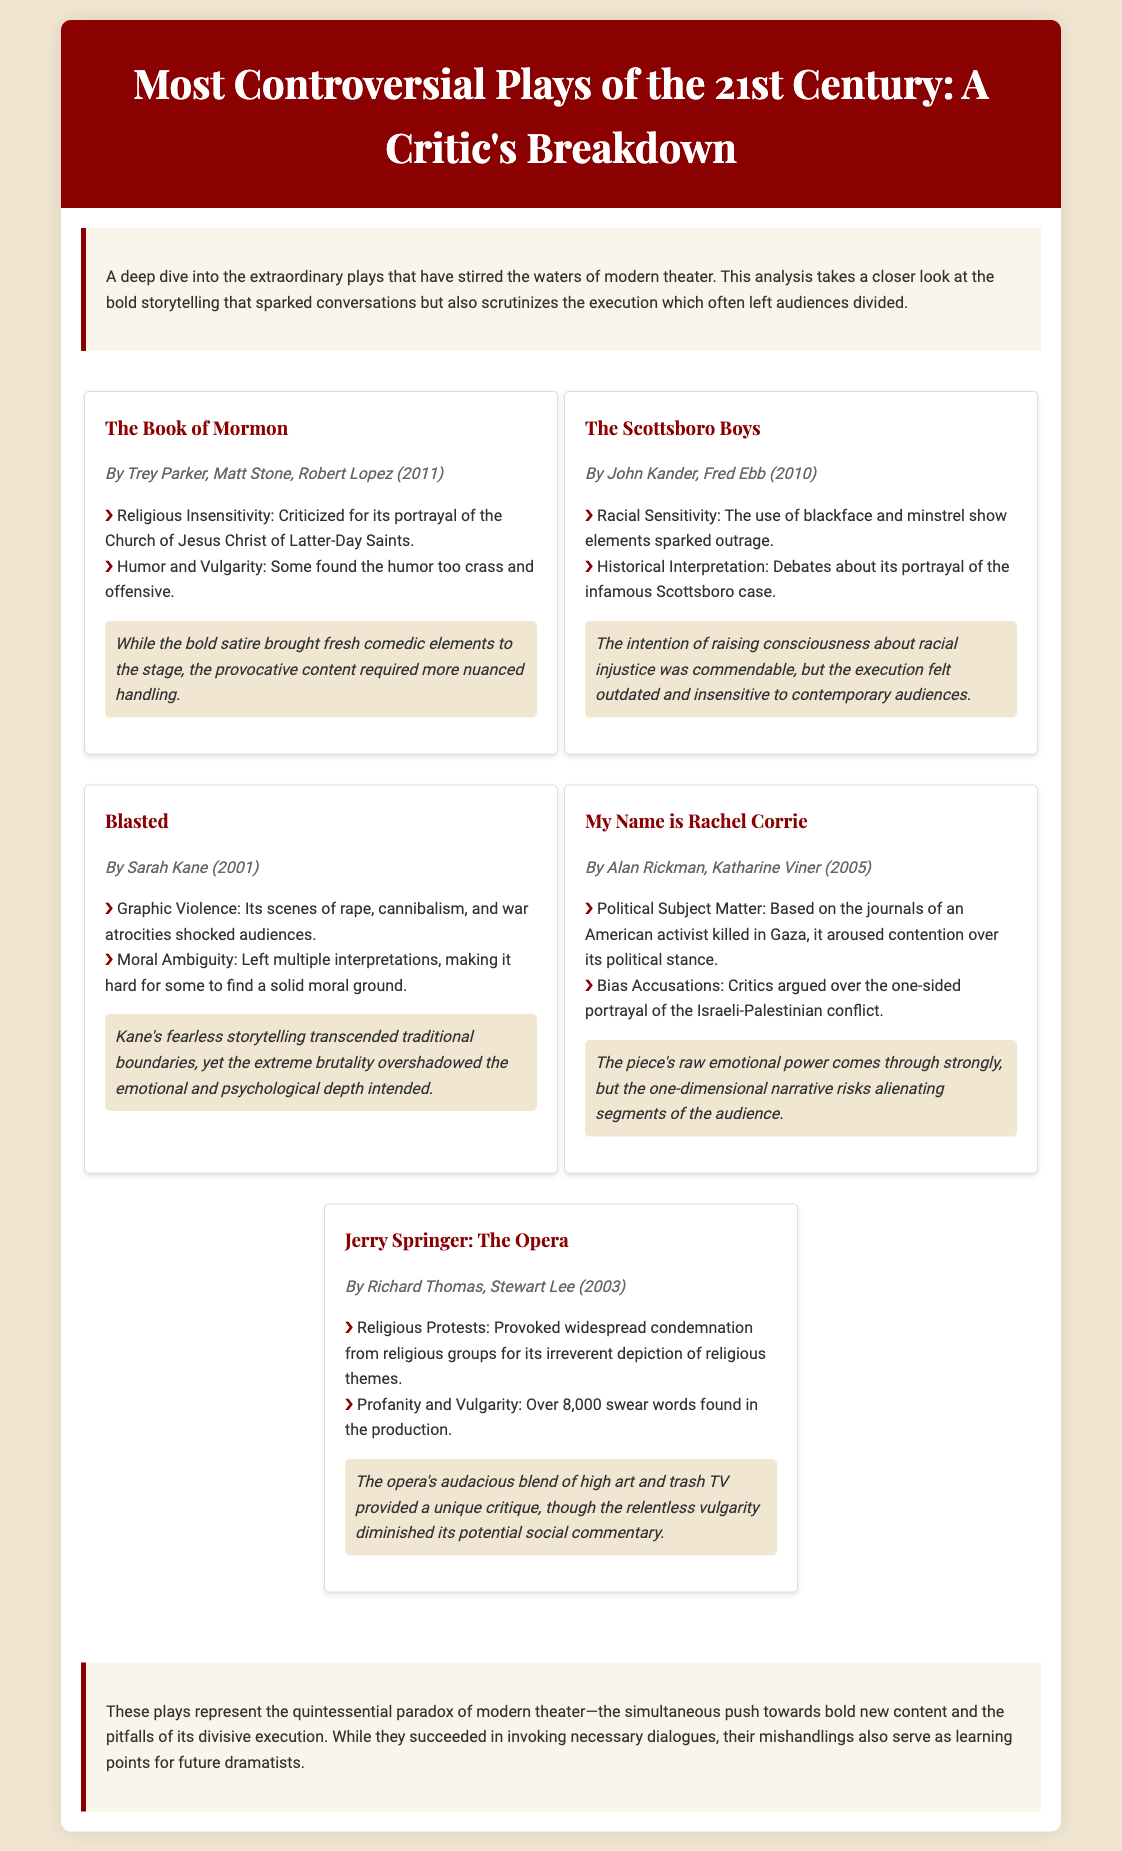What is the title of the first play listed? The title of the first play in the document is explicitly mentioned at the beginning of its section.
Answer: The Book of Mormon Who are the authors of "Blasted"? The authors of "Blasted" are mentioned in the play's information section.
Answer: Sarah Kane How many swear words are found in "Jerry Springer: The Opera"? The document states the exact number of swear words featured in the production within its controversies section.
Answer: Over 8,000 What year was "My Name is Rachel Corrie" published? The publication year for "My Name is Rachel Corrie" is provided in the play’s information section.
Answer: 2005 Which play dealt with the topic of racial sensitivity? The document lists controversies concerning racial sensitivity along with their associated plays.
Answer: The Scottsboro Boys What is the main criticism of "The Book of Mormon"? The document details specific controversies associated with "The Book of Mormon," highlighting the main criticism in its synopsis.
Answer: Religious Insensitivity What common theme is highlighted in the conclusion of the document? The conclusion summarizes the overall critique of the plays regarding the execution of bold storytelling as a common theme.
Answer: Bold new content and divisive execution 